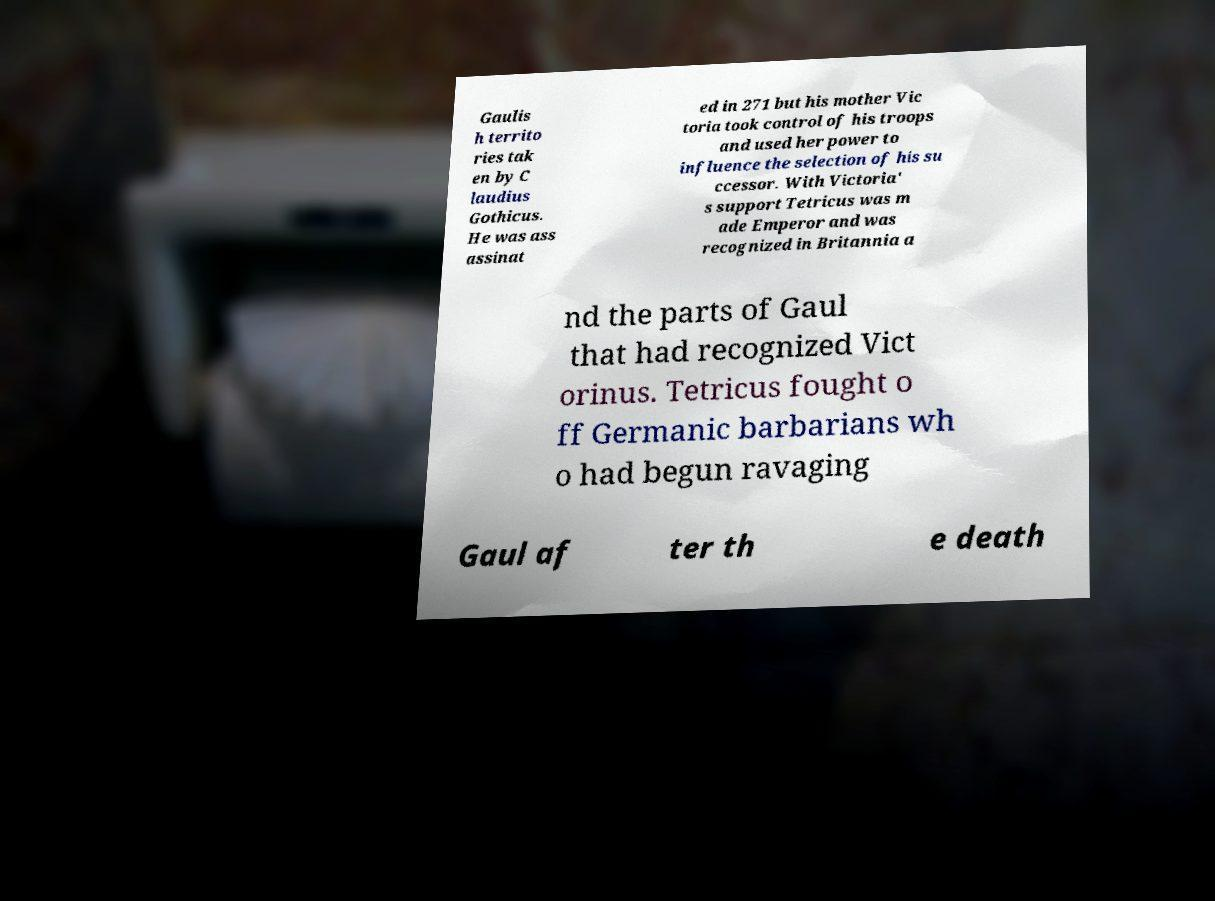Please read and relay the text visible in this image. What does it say? Gaulis h territo ries tak en by C laudius Gothicus. He was ass assinat ed in 271 but his mother Vic toria took control of his troops and used her power to influence the selection of his su ccessor. With Victoria' s support Tetricus was m ade Emperor and was recognized in Britannia a nd the parts of Gaul that had recognized Vict orinus. Tetricus fought o ff Germanic barbarians wh o had begun ravaging Gaul af ter th e death 